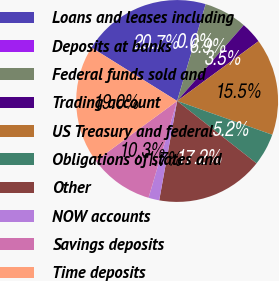<chart> <loc_0><loc_0><loc_500><loc_500><pie_chart><fcel>Loans and leases including<fcel>Deposits at banks<fcel>Federal funds sold and<fcel>Trading account<fcel>US Treasury and federal<fcel>Obligations of states and<fcel>Other<fcel>NOW accounts<fcel>Savings deposits<fcel>Time deposits<nl><fcel>20.68%<fcel>0.01%<fcel>6.9%<fcel>3.45%<fcel>15.51%<fcel>5.17%<fcel>17.24%<fcel>1.73%<fcel>10.34%<fcel>18.96%<nl></chart> 